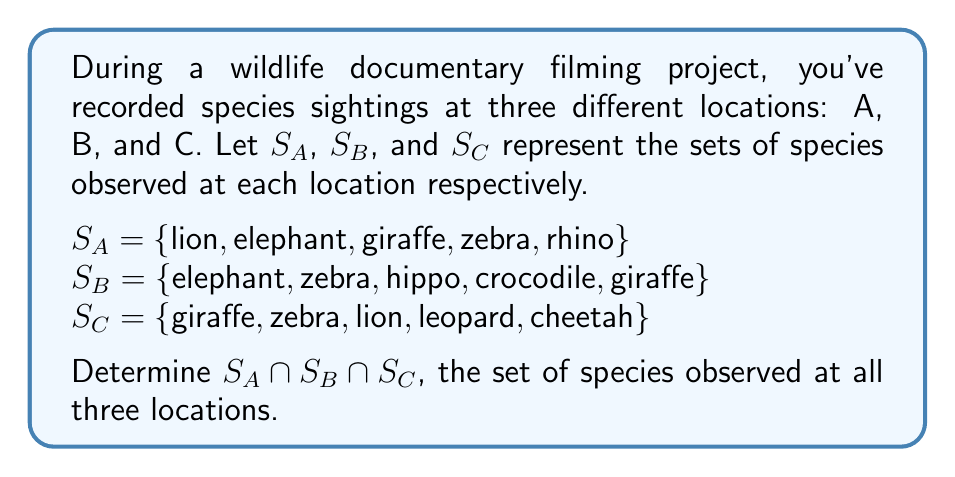Can you answer this question? To find the intersection of these three sets, we need to identify the species that are common to all three locations. Let's approach this step-by-step:

1) First, let's identify the species that are in at least two sets:
   - Lion: in $S_A$ and $S_C$
   - Elephant: in $S_A$ and $S_B$
   - Giraffe: in $S_A$, $S_B$, and $S_C$
   - Zebra: in $S_A$, $S_B$, and $S_C$
   - Rhino: only in $S_A$
   - Hippo: only in $S_B$
   - Crocodile: only in $S_B$
   - Leopard: only in $S_C$
   - Cheetah: only in $S_C$

2) From this list, we can see that only giraffe and zebra appear in all three sets.

3) Therefore, the intersection of the three sets, $S_A \cap S_B \cap S_C$, contains only these two species.

This result is useful for a wildlife documentary producer as it identifies the species that are consistently present across all filming locations, which could be important for planning shots or structuring the narrative of the documentary.
Answer: $S_A \cap S_B \cap S_C = \{giraffe, zebra\}$ 